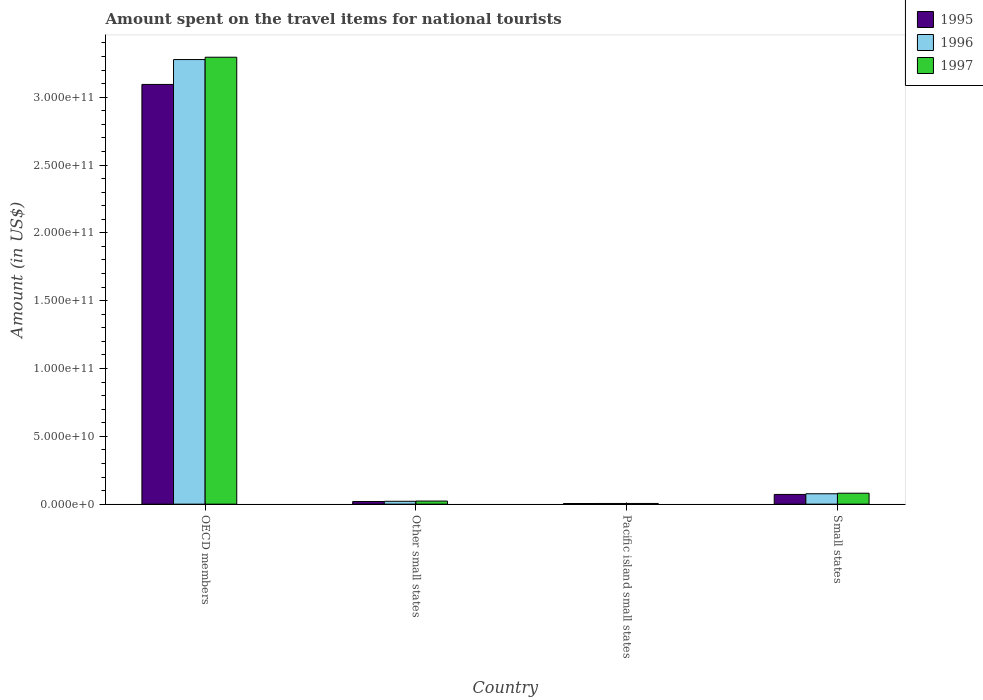How many different coloured bars are there?
Give a very brief answer. 3. How many groups of bars are there?
Provide a short and direct response. 4. Are the number of bars per tick equal to the number of legend labels?
Ensure brevity in your answer.  Yes. What is the amount spent on the travel items for national tourists in 1996 in OECD members?
Your answer should be compact. 3.28e+11. Across all countries, what is the maximum amount spent on the travel items for national tourists in 1995?
Your response must be concise. 3.09e+11. Across all countries, what is the minimum amount spent on the travel items for national tourists in 1995?
Give a very brief answer. 4.74e+08. In which country was the amount spent on the travel items for national tourists in 1996 minimum?
Give a very brief answer. Pacific island small states. What is the total amount spent on the travel items for national tourists in 1995 in the graph?
Keep it short and to the point. 3.19e+11. What is the difference between the amount spent on the travel items for national tourists in 1995 in OECD members and that in Other small states?
Give a very brief answer. 3.07e+11. What is the difference between the amount spent on the travel items for national tourists in 1996 in Other small states and the amount spent on the travel items for national tourists in 1997 in Small states?
Offer a very short reply. -5.95e+09. What is the average amount spent on the travel items for national tourists in 1996 per country?
Keep it short and to the point. 8.45e+1. What is the difference between the amount spent on the travel items for national tourists of/in 1997 and amount spent on the travel items for national tourists of/in 1996 in Pacific island small states?
Give a very brief answer. 1.22e+07. What is the ratio of the amount spent on the travel items for national tourists in 1997 in OECD members to that in Small states?
Make the answer very short. 40.82. Is the difference between the amount spent on the travel items for national tourists in 1997 in Other small states and Small states greater than the difference between the amount spent on the travel items for national tourists in 1996 in Other small states and Small states?
Your answer should be very brief. No. What is the difference between the highest and the second highest amount spent on the travel items for national tourists in 1995?
Offer a very short reply. 3.02e+11. What is the difference between the highest and the lowest amount spent on the travel items for national tourists in 1997?
Your response must be concise. 3.29e+11. In how many countries, is the amount spent on the travel items for national tourists in 1996 greater than the average amount spent on the travel items for national tourists in 1996 taken over all countries?
Offer a terse response. 1. Is it the case that in every country, the sum of the amount spent on the travel items for national tourists in 1996 and amount spent on the travel items for national tourists in 1997 is greater than the amount spent on the travel items for national tourists in 1995?
Your answer should be very brief. Yes. How many bars are there?
Provide a short and direct response. 12. Are all the bars in the graph horizontal?
Your answer should be compact. No. Are the values on the major ticks of Y-axis written in scientific E-notation?
Provide a succinct answer. Yes. Where does the legend appear in the graph?
Your answer should be compact. Top right. How many legend labels are there?
Your answer should be compact. 3. What is the title of the graph?
Provide a short and direct response. Amount spent on the travel items for national tourists. What is the label or title of the X-axis?
Your response must be concise. Country. What is the label or title of the Y-axis?
Keep it short and to the point. Amount (in US$). What is the Amount (in US$) in 1995 in OECD members?
Your answer should be compact. 3.09e+11. What is the Amount (in US$) of 1996 in OECD members?
Keep it short and to the point. 3.28e+11. What is the Amount (in US$) in 1997 in OECD members?
Your response must be concise. 3.29e+11. What is the Amount (in US$) in 1995 in Other small states?
Provide a succinct answer. 1.95e+09. What is the Amount (in US$) of 1996 in Other small states?
Provide a succinct answer. 2.12e+09. What is the Amount (in US$) in 1997 in Other small states?
Provide a succinct answer. 2.29e+09. What is the Amount (in US$) of 1995 in Pacific island small states?
Offer a very short reply. 4.74e+08. What is the Amount (in US$) of 1996 in Pacific island small states?
Your answer should be compact. 5.03e+08. What is the Amount (in US$) in 1997 in Pacific island small states?
Offer a very short reply. 5.15e+08. What is the Amount (in US$) of 1995 in Small states?
Give a very brief answer. 7.16e+09. What is the Amount (in US$) of 1996 in Small states?
Provide a short and direct response. 7.67e+09. What is the Amount (in US$) in 1997 in Small states?
Make the answer very short. 8.07e+09. Across all countries, what is the maximum Amount (in US$) in 1995?
Provide a succinct answer. 3.09e+11. Across all countries, what is the maximum Amount (in US$) of 1996?
Provide a succinct answer. 3.28e+11. Across all countries, what is the maximum Amount (in US$) in 1997?
Your response must be concise. 3.29e+11. Across all countries, what is the minimum Amount (in US$) in 1995?
Provide a succinct answer. 4.74e+08. Across all countries, what is the minimum Amount (in US$) in 1996?
Ensure brevity in your answer.  5.03e+08. Across all countries, what is the minimum Amount (in US$) in 1997?
Give a very brief answer. 5.15e+08. What is the total Amount (in US$) of 1995 in the graph?
Your response must be concise. 3.19e+11. What is the total Amount (in US$) in 1996 in the graph?
Your answer should be very brief. 3.38e+11. What is the total Amount (in US$) in 1997 in the graph?
Provide a short and direct response. 3.40e+11. What is the difference between the Amount (in US$) in 1995 in OECD members and that in Other small states?
Offer a terse response. 3.07e+11. What is the difference between the Amount (in US$) in 1996 in OECD members and that in Other small states?
Keep it short and to the point. 3.26e+11. What is the difference between the Amount (in US$) in 1997 in OECD members and that in Other small states?
Provide a succinct answer. 3.27e+11. What is the difference between the Amount (in US$) of 1995 in OECD members and that in Pacific island small states?
Your answer should be compact. 3.09e+11. What is the difference between the Amount (in US$) of 1996 in OECD members and that in Pacific island small states?
Provide a short and direct response. 3.27e+11. What is the difference between the Amount (in US$) of 1997 in OECD members and that in Pacific island small states?
Give a very brief answer. 3.29e+11. What is the difference between the Amount (in US$) of 1995 in OECD members and that in Small states?
Provide a succinct answer. 3.02e+11. What is the difference between the Amount (in US$) in 1996 in OECD members and that in Small states?
Offer a terse response. 3.20e+11. What is the difference between the Amount (in US$) of 1997 in OECD members and that in Small states?
Offer a very short reply. 3.21e+11. What is the difference between the Amount (in US$) in 1995 in Other small states and that in Pacific island small states?
Keep it short and to the point. 1.48e+09. What is the difference between the Amount (in US$) of 1996 in Other small states and that in Pacific island small states?
Provide a short and direct response. 1.62e+09. What is the difference between the Amount (in US$) of 1997 in Other small states and that in Pacific island small states?
Offer a terse response. 1.77e+09. What is the difference between the Amount (in US$) in 1995 in Other small states and that in Small states?
Give a very brief answer. -5.21e+09. What is the difference between the Amount (in US$) of 1996 in Other small states and that in Small states?
Offer a very short reply. -5.55e+09. What is the difference between the Amount (in US$) of 1997 in Other small states and that in Small states?
Provide a succinct answer. -5.78e+09. What is the difference between the Amount (in US$) in 1995 in Pacific island small states and that in Small states?
Your answer should be compact. -6.69e+09. What is the difference between the Amount (in US$) of 1996 in Pacific island small states and that in Small states?
Ensure brevity in your answer.  -7.16e+09. What is the difference between the Amount (in US$) in 1997 in Pacific island small states and that in Small states?
Your answer should be very brief. -7.56e+09. What is the difference between the Amount (in US$) in 1995 in OECD members and the Amount (in US$) in 1996 in Other small states?
Ensure brevity in your answer.  3.07e+11. What is the difference between the Amount (in US$) in 1995 in OECD members and the Amount (in US$) in 1997 in Other small states?
Your response must be concise. 3.07e+11. What is the difference between the Amount (in US$) of 1996 in OECD members and the Amount (in US$) of 1997 in Other small states?
Give a very brief answer. 3.25e+11. What is the difference between the Amount (in US$) in 1995 in OECD members and the Amount (in US$) in 1996 in Pacific island small states?
Make the answer very short. 3.09e+11. What is the difference between the Amount (in US$) of 1995 in OECD members and the Amount (in US$) of 1997 in Pacific island small states?
Ensure brevity in your answer.  3.09e+11. What is the difference between the Amount (in US$) in 1996 in OECD members and the Amount (in US$) in 1997 in Pacific island small states?
Offer a very short reply. 3.27e+11. What is the difference between the Amount (in US$) in 1995 in OECD members and the Amount (in US$) in 1996 in Small states?
Offer a very short reply. 3.02e+11. What is the difference between the Amount (in US$) in 1995 in OECD members and the Amount (in US$) in 1997 in Small states?
Your answer should be very brief. 3.01e+11. What is the difference between the Amount (in US$) of 1996 in OECD members and the Amount (in US$) of 1997 in Small states?
Make the answer very short. 3.20e+11. What is the difference between the Amount (in US$) of 1995 in Other small states and the Amount (in US$) of 1996 in Pacific island small states?
Keep it short and to the point. 1.45e+09. What is the difference between the Amount (in US$) of 1995 in Other small states and the Amount (in US$) of 1997 in Pacific island small states?
Provide a succinct answer. 1.44e+09. What is the difference between the Amount (in US$) of 1996 in Other small states and the Amount (in US$) of 1997 in Pacific island small states?
Your response must be concise. 1.60e+09. What is the difference between the Amount (in US$) of 1995 in Other small states and the Amount (in US$) of 1996 in Small states?
Your answer should be very brief. -5.71e+09. What is the difference between the Amount (in US$) in 1995 in Other small states and the Amount (in US$) in 1997 in Small states?
Keep it short and to the point. -6.12e+09. What is the difference between the Amount (in US$) of 1996 in Other small states and the Amount (in US$) of 1997 in Small states?
Offer a very short reply. -5.95e+09. What is the difference between the Amount (in US$) in 1995 in Pacific island small states and the Amount (in US$) in 1996 in Small states?
Your response must be concise. -7.19e+09. What is the difference between the Amount (in US$) of 1995 in Pacific island small states and the Amount (in US$) of 1997 in Small states?
Offer a terse response. -7.60e+09. What is the difference between the Amount (in US$) of 1996 in Pacific island small states and the Amount (in US$) of 1997 in Small states?
Offer a terse response. -7.57e+09. What is the average Amount (in US$) in 1995 per country?
Offer a very short reply. 7.98e+1. What is the average Amount (in US$) of 1996 per country?
Offer a very short reply. 8.45e+1. What is the average Amount (in US$) in 1997 per country?
Keep it short and to the point. 8.51e+1. What is the difference between the Amount (in US$) in 1995 and Amount (in US$) in 1996 in OECD members?
Keep it short and to the point. -1.83e+1. What is the difference between the Amount (in US$) of 1995 and Amount (in US$) of 1997 in OECD members?
Offer a very short reply. -2.01e+1. What is the difference between the Amount (in US$) in 1996 and Amount (in US$) in 1997 in OECD members?
Provide a succinct answer. -1.72e+09. What is the difference between the Amount (in US$) in 1995 and Amount (in US$) in 1996 in Other small states?
Your answer should be very brief. -1.64e+08. What is the difference between the Amount (in US$) of 1995 and Amount (in US$) of 1997 in Other small states?
Keep it short and to the point. -3.34e+08. What is the difference between the Amount (in US$) of 1996 and Amount (in US$) of 1997 in Other small states?
Provide a short and direct response. -1.69e+08. What is the difference between the Amount (in US$) in 1995 and Amount (in US$) in 1996 in Pacific island small states?
Provide a short and direct response. -2.89e+07. What is the difference between the Amount (in US$) in 1995 and Amount (in US$) in 1997 in Pacific island small states?
Provide a succinct answer. -4.11e+07. What is the difference between the Amount (in US$) in 1996 and Amount (in US$) in 1997 in Pacific island small states?
Offer a terse response. -1.22e+07. What is the difference between the Amount (in US$) in 1995 and Amount (in US$) in 1996 in Small states?
Provide a succinct answer. -5.07e+08. What is the difference between the Amount (in US$) of 1995 and Amount (in US$) of 1997 in Small states?
Give a very brief answer. -9.12e+08. What is the difference between the Amount (in US$) in 1996 and Amount (in US$) in 1997 in Small states?
Your answer should be compact. -4.05e+08. What is the ratio of the Amount (in US$) in 1995 in OECD members to that in Other small states?
Your answer should be very brief. 158.36. What is the ratio of the Amount (in US$) in 1996 in OECD members to that in Other small states?
Provide a short and direct response. 154.72. What is the ratio of the Amount (in US$) of 1997 in OECD members to that in Other small states?
Offer a very short reply. 144.02. What is the ratio of the Amount (in US$) in 1995 in OECD members to that in Pacific island small states?
Your answer should be compact. 652.87. What is the ratio of the Amount (in US$) in 1996 in OECD members to that in Pacific island small states?
Ensure brevity in your answer.  651.78. What is the ratio of the Amount (in US$) in 1997 in OECD members to that in Pacific island small states?
Your answer should be very brief. 639.7. What is the ratio of the Amount (in US$) in 1995 in OECD members to that in Small states?
Provide a short and direct response. 43.22. What is the ratio of the Amount (in US$) of 1996 in OECD members to that in Small states?
Make the answer very short. 42.76. What is the ratio of the Amount (in US$) in 1997 in OECD members to that in Small states?
Your answer should be compact. 40.82. What is the ratio of the Amount (in US$) in 1995 in Other small states to that in Pacific island small states?
Your answer should be very brief. 4.12. What is the ratio of the Amount (in US$) in 1996 in Other small states to that in Pacific island small states?
Offer a very short reply. 4.21. What is the ratio of the Amount (in US$) of 1997 in Other small states to that in Pacific island small states?
Give a very brief answer. 4.44. What is the ratio of the Amount (in US$) of 1995 in Other small states to that in Small states?
Your response must be concise. 0.27. What is the ratio of the Amount (in US$) of 1996 in Other small states to that in Small states?
Your response must be concise. 0.28. What is the ratio of the Amount (in US$) of 1997 in Other small states to that in Small states?
Ensure brevity in your answer.  0.28. What is the ratio of the Amount (in US$) in 1995 in Pacific island small states to that in Small states?
Make the answer very short. 0.07. What is the ratio of the Amount (in US$) in 1996 in Pacific island small states to that in Small states?
Provide a succinct answer. 0.07. What is the ratio of the Amount (in US$) of 1997 in Pacific island small states to that in Small states?
Your answer should be compact. 0.06. What is the difference between the highest and the second highest Amount (in US$) of 1995?
Provide a succinct answer. 3.02e+11. What is the difference between the highest and the second highest Amount (in US$) of 1996?
Ensure brevity in your answer.  3.20e+11. What is the difference between the highest and the second highest Amount (in US$) in 1997?
Provide a short and direct response. 3.21e+11. What is the difference between the highest and the lowest Amount (in US$) in 1995?
Give a very brief answer. 3.09e+11. What is the difference between the highest and the lowest Amount (in US$) in 1996?
Provide a succinct answer. 3.27e+11. What is the difference between the highest and the lowest Amount (in US$) in 1997?
Provide a succinct answer. 3.29e+11. 